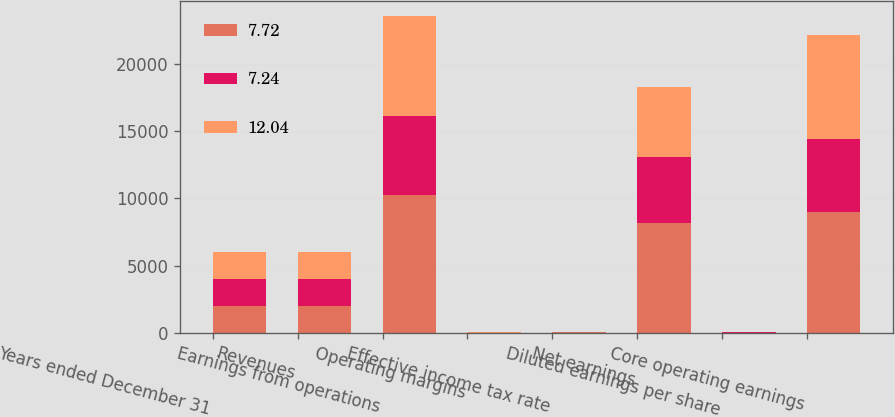Convert chart. <chart><loc_0><loc_0><loc_500><loc_500><stacked_bar_chart><ecel><fcel>Years ended December 31<fcel>Revenues<fcel>Earnings from operations<fcel>Operating margins<fcel>Effective income tax rate<fcel>Net earnings<fcel>Diluted earnings per share<fcel>Core operating earnings<nl><fcel>7.72<fcel>2017<fcel>2016<fcel>10278<fcel>11<fcel>18.4<fcel>8197<fcel>13.43<fcel>8970<nl><fcel>7.24<fcel>2016<fcel>2016<fcel>5834<fcel>6.2<fcel>12.1<fcel>4895<fcel>7.61<fcel>5464<nl><fcel>12.04<fcel>2015<fcel>2016<fcel>7443<fcel>7.7<fcel>27.7<fcel>5176<fcel>7.44<fcel>7741<nl></chart> 